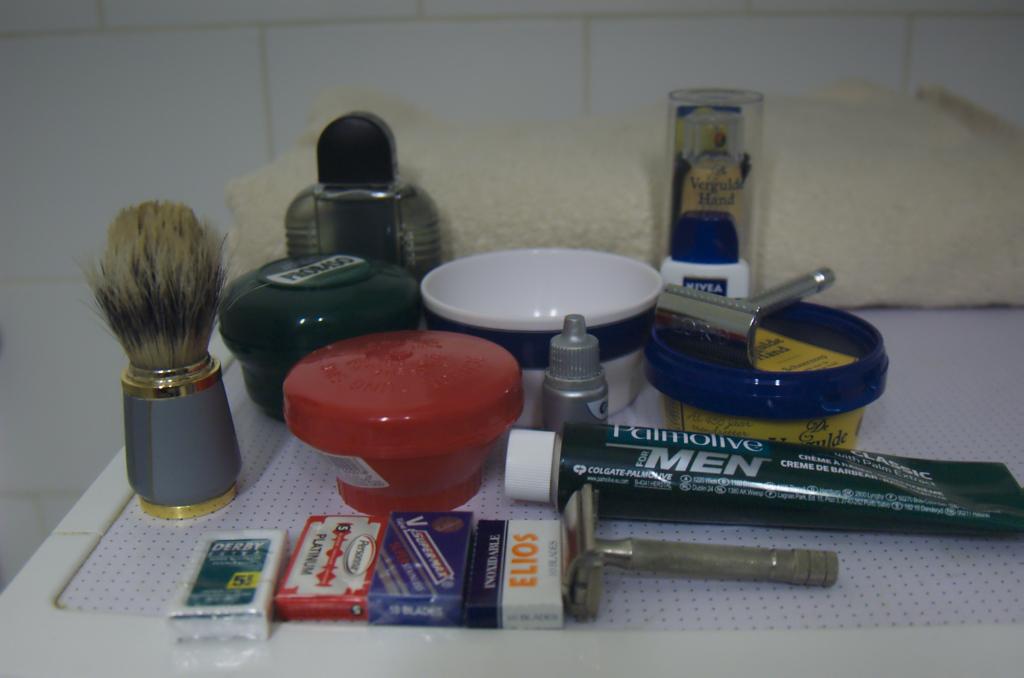What gender are these products mostly for?
Ensure brevity in your answer.  Men. 